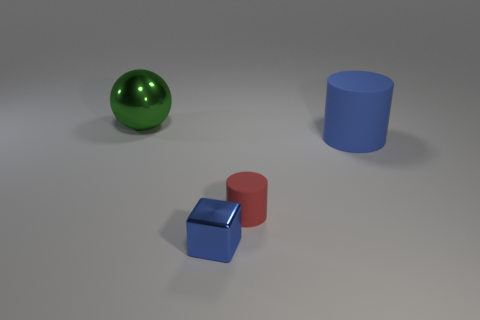Is there a large green metallic ball that is right of the big thing that is in front of the ball?
Your answer should be compact. No. Are there any metallic spheres of the same size as the red rubber object?
Offer a very short reply. No. Is the color of the thing that is right of the tiny red matte cylinder the same as the shiny block?
Make the answer very short. Yes. What is the size of the green metal thing?
Give a very brief answer. Large. What size is the cylinder to the right of the small object that is behind the small block?
Give a very brief answer. Large. How many shiny balls have the same color as the large cylinder?
Provide a succinct answer. 0. What number of matte objects are there?
Your response must be concise. 2. How many balls have the same material as the small block?
Offer a very short reply. 1. What is the size of the red matte thing that is the same shape as the big blue rubber thing?
Offer a terse response. Small. What is the material of the small cube?
Provide a short and direct response. Metal. 